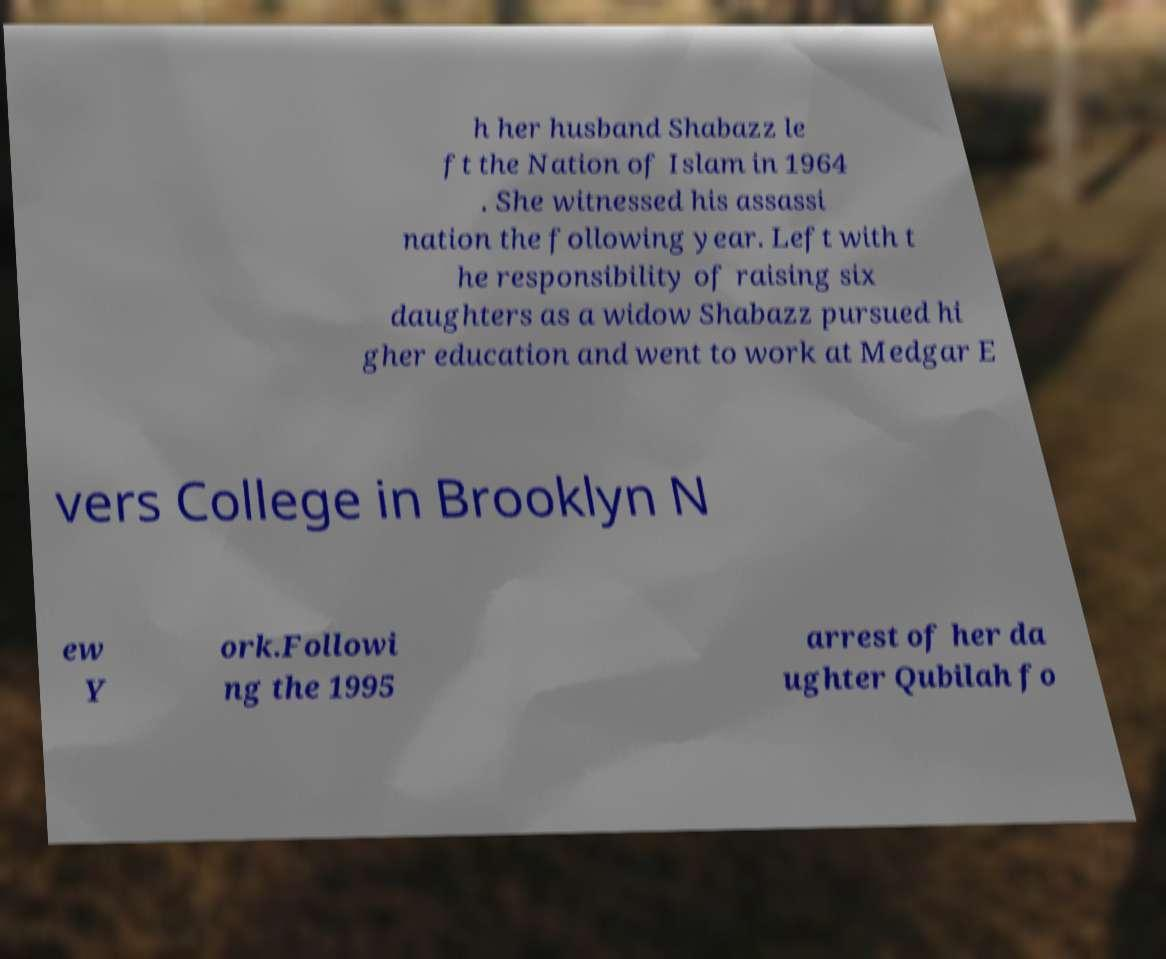For documentation purposes, I need the text within this image transcribed. Could you provide that? h her husband Shabazz le ft the Nation of Islam in 1964 . She witnessed his assassi nation the following year. Left with t he responsibility of raising six daughters as a widow Shabazz pursued hi gher education and went to work at Medgar E vers College in Brooklyn N ew Y ork.Followi ng the 1995 arrest of her da ughter Qubilah fo 